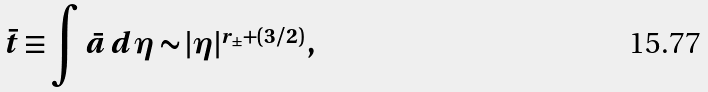<formula> <loc_0><loc_0><loc_500><loc_500>\bar { t } \equiv \int \bar { a } \, d \eta \sim | \eta | ^ { r _ { \pm } + ( 3 / 2 ) } \, ,</formula> 